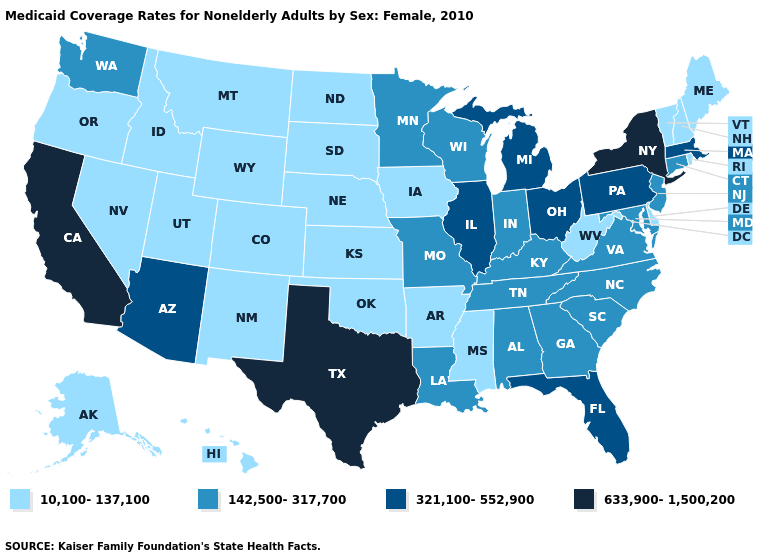Among the states that border Massachusetts , which have the lowest value?
Be succinct. New Hampshire, Rhode Island, Vermont. Does Kentucky have the lowest value in the USA?
Give a very brief answer. No. What is the value of Nebraska?
Short answer required. 10,100-137,100. Which states have the lowest value in the USA?
Quick response, please. Alaska, Arkansas, Colorado, Delaware, Hawaii, Idaho, Iowa, Kansas, Maine, Mississippi, Montana, Nebraska, Nevada, New Hampshire, New Mexico, North Dakota, Oklahoma, Oregon, Rhode Island, South Dakota, Utah, Vermont, West Virginia, Wyoming. Among the states that border Maryland , which have the highest value?
Give a very brief answer. Pennsylvania. Does California have the highest value in the West?
Write a very short answer. Yes. Among the states that border Virginia , which have the lowest value?
Concise answer only. West Virginia. Which states hav the highest value in the MidWest?
Be succinct. Illinois, Michigan, Ohio. What is the value of Arkansas?
Be succinct. 10,100-137,100. Does the first symbol in the legend represent the smallest category?
Concise answer only. Yes. Which states have the lowest value in the USA?
Be succinct. Alaska, Arkansas, Colorado, Delaware, Hawaii, Idaho, Iowa, Kansas, Maine, Mississippi, Montana, Nebraska, Nevada, New Hampshire, New Mexico, North Dakota, Oklahoma, Oregon, Rhode Island, South Dakota, Utah, Vermont, West Virginia, Wyoming. Among the states that border Oklahoma , which have the highest value?
Quick response, please. Texas. What is the highest value in states that border Colorado?
Concise answer only. 321,100-552,900. Does Illinois have the lowest value in the USA?
Write a very short answer. No. What is the value of Tennessee?
Short answer required. 142,500-317,700. 